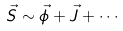Convert formula to latex. <formula><loc_0><loc_0><loc_500><loc_500>\vec { S } \sim \vec { \phi } + \vec { J } + \cdots</formula> 